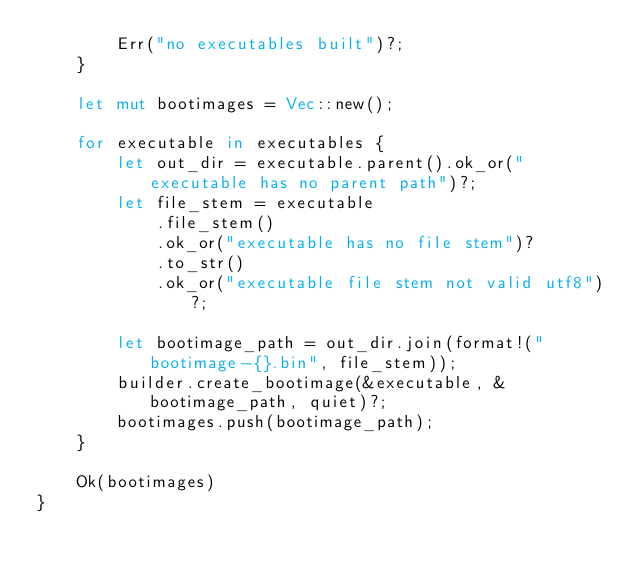<code> <loc_0><loc_0><loc_500><loc_500><_Rust_>        Err("no executables built")?;
    }

    let mut bootimages = Vec::new();

    for executable in executables {
        let out_dir = executable.parent().ok_or("executable has no parent path")?;
        let file_stem = executable
            .file_stem()
            .ok_or("executable has no file stem")?
            .to_str()
            .ok_or("executable file stem not valid utf8")?;

        let bootimage_path = out_dir.join(format!("bootimage-{}.bin", file_stem));
        builder.create_bootimage(&executable, &bootimage_path, quiet)?;
        bootimages.push(bootimage_path);
    }

    Ok(bootimages)
}
</code> 